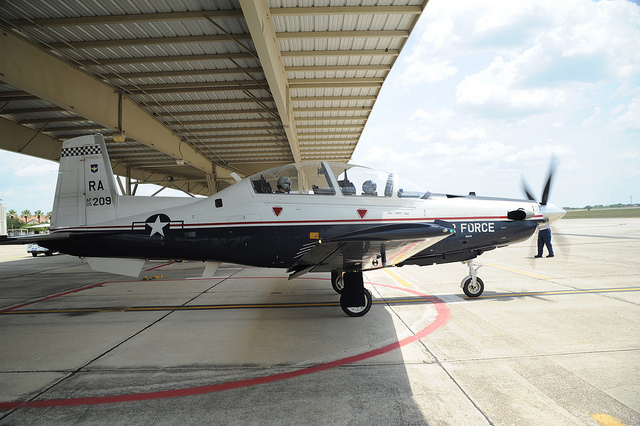Please transcribe the text information in this image. FORCE RA 209 